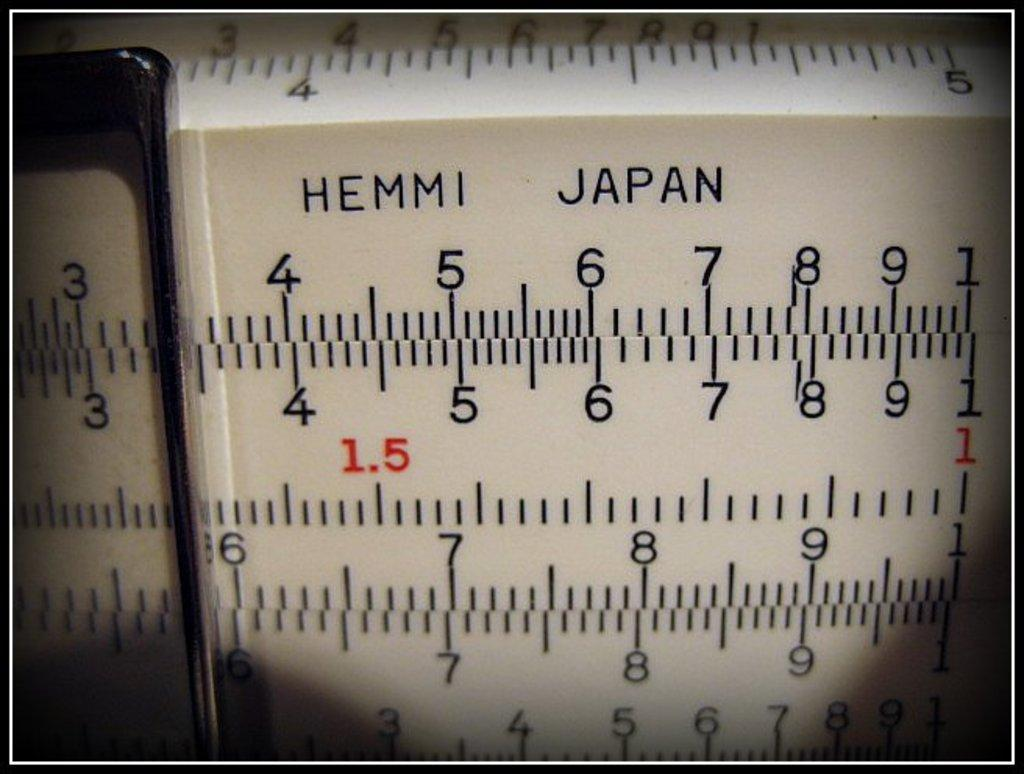<image>
Relay a brief, clear account of the picture shown. Hemmi Japan that contains numbers that are black and red 